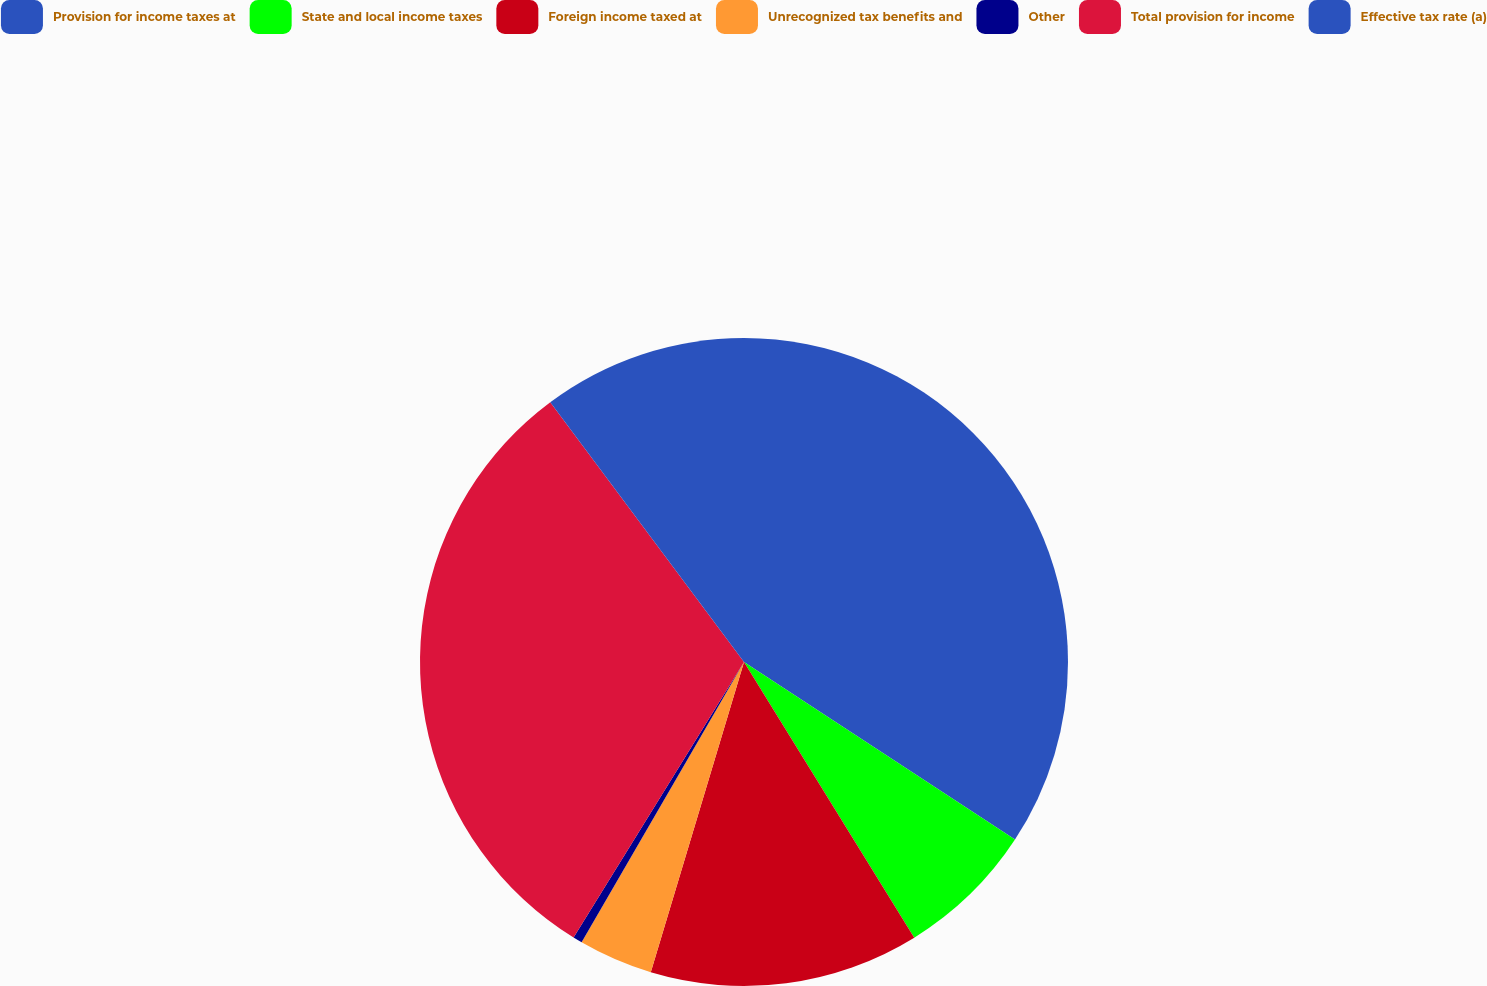Convert chart. <chart><loc_0><loc_0><loc_500><loc_500><pie_chart><fcel>Provision for income taxes at<fcel>State and local income taxes<fcel>Foreign income taxed at<fcel>Unrecognized tax benefits and<fcel>Other<fcel>Total provision for income<fcel>Effective tax rate (a)<nl><fcel>34.23%<fcel>6.96%<fcel>13.45%<fcel>3.71%<fcel>0.46%<fcel>30.98%<fcel>10.2%<nl></chart> 